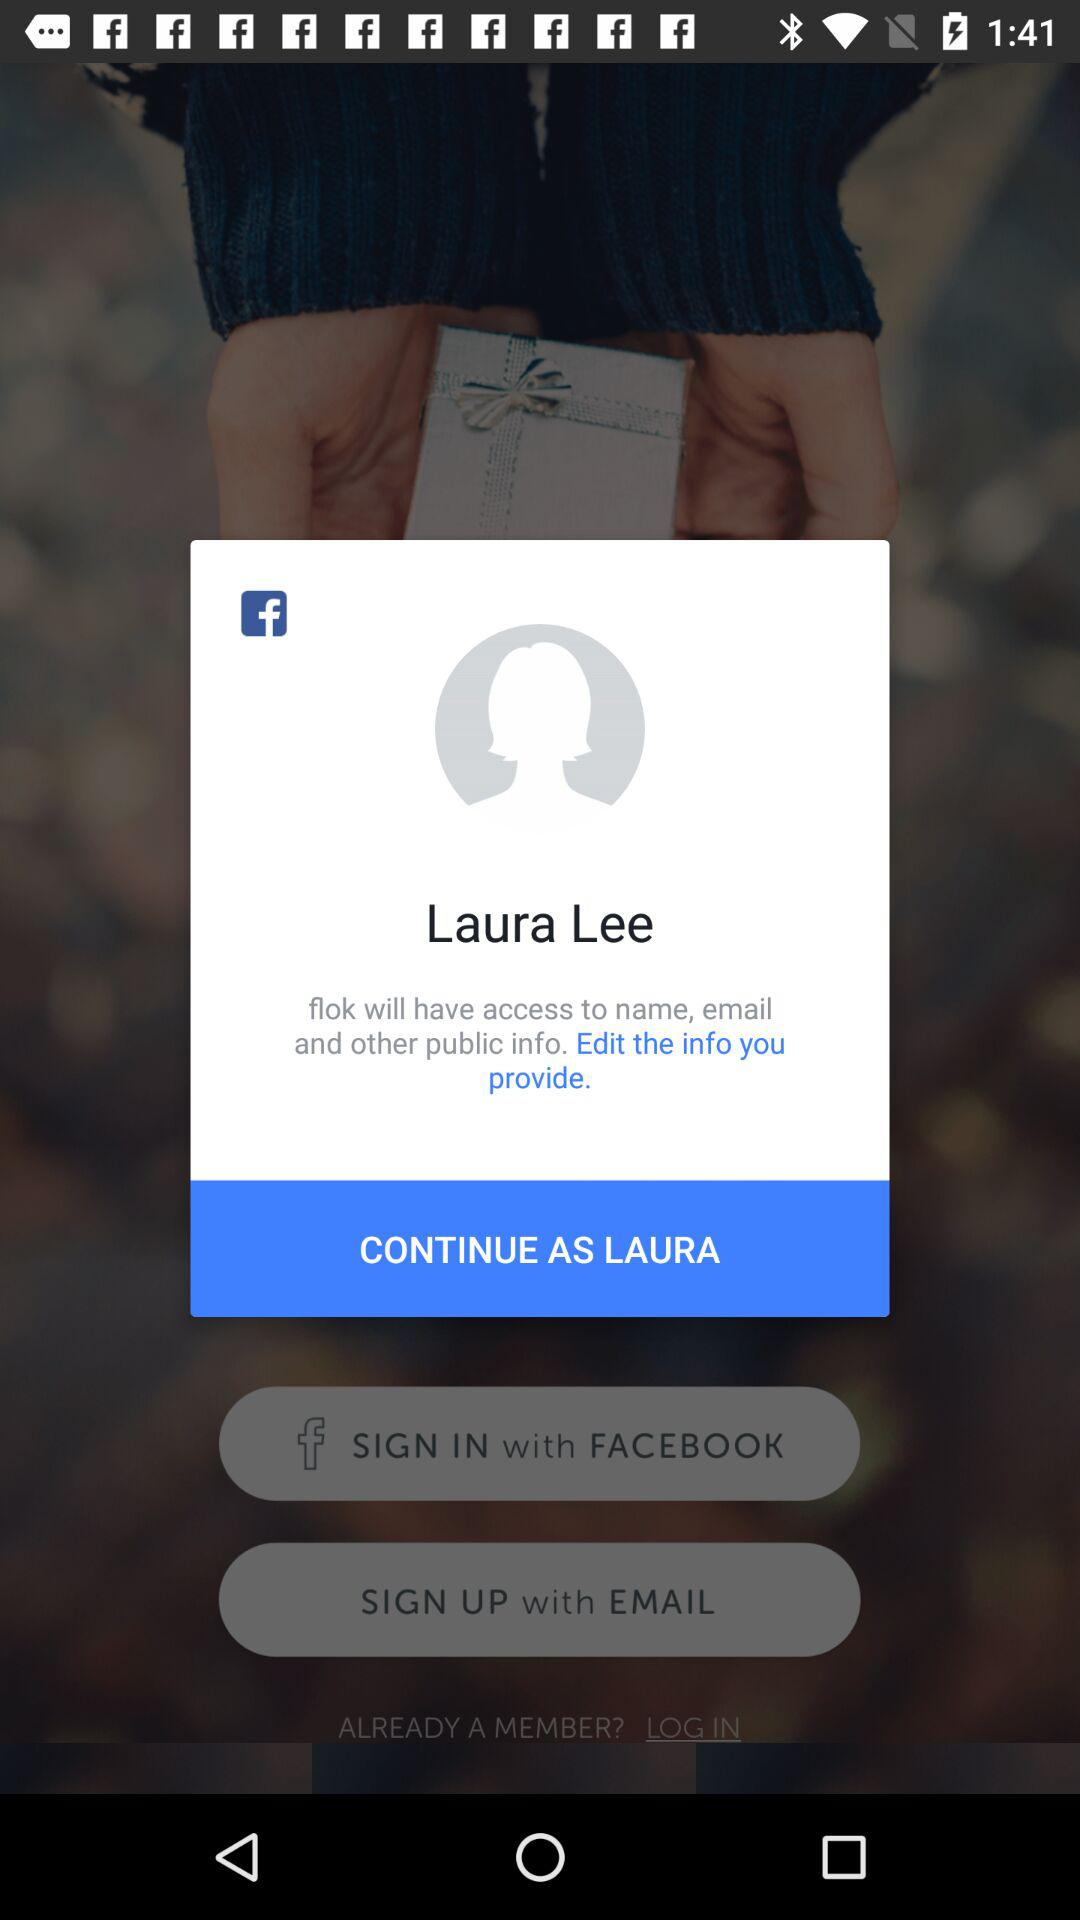How many public information fields does Flok have access to?
Answer the question using a single word or phrase. 3 